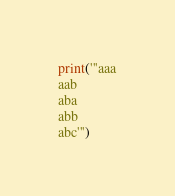<code> <loc_0><loc_0><loc_500><loc_500><_Python_>print('''aaa
aab
aba
abb
abc''')</code> 